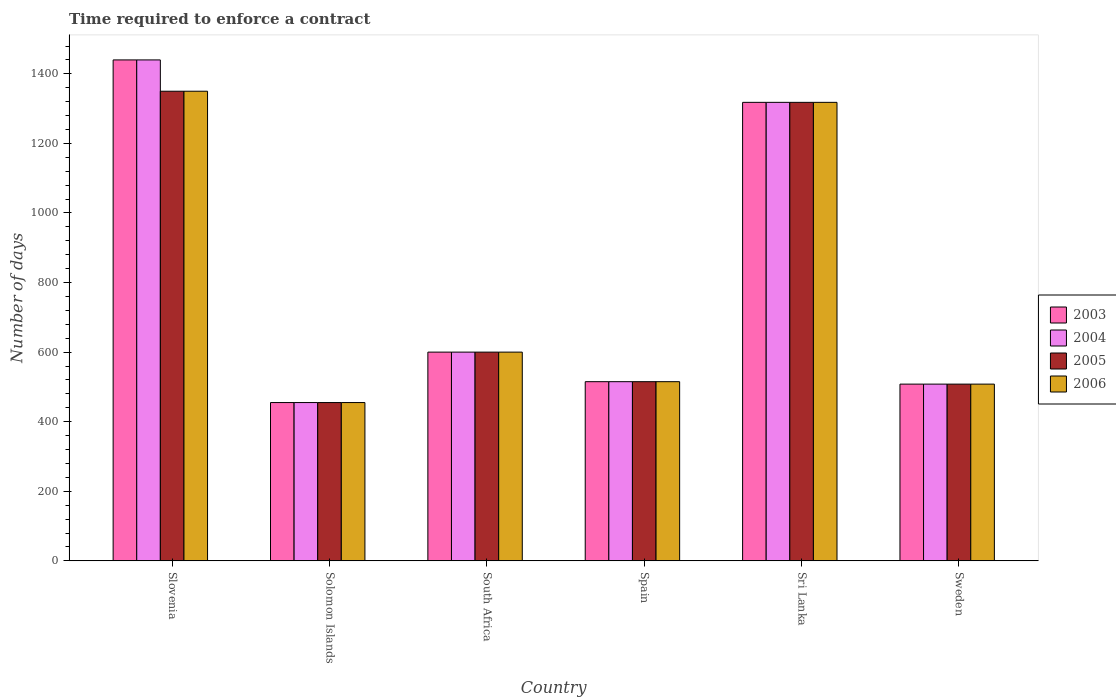How many different coloured bars are there?
Provide a succinct answer. 4. How many groups of bars are there?
Offer a terse response. 6. Are the number of bars per tick equal to the number of legend labels?
Your answer should be very brief. Yes. How many bars are there on the 6th tick from the left?
Offer a very short reply. 4. What is the label of the 5th group of bars from the left?
Give a very brief answer. Sri Lanka. What is the number of days required to enforce a contract in 2005 in Sweden?
Make the answer very short. 508. Across all countries, what is the maximum number of days required to enforce a contract in 2004?
Make the answer very short. 1440. Across all countries, what is the minimum number of days required to enforce a contract in 2005?
Ensure brevity in your answer.  455. In which country was the number of days required to enforce a contract in 2004 maximum?
Offer a very short reply. Slovenia. In which country was the number of days required to enforce a contract in 2004 minimum?
Give a very brief answer. Solomon Islands. What is the total number of days required to enforce a contract in 2006 in the graph?
Your answer should be compact. 4746. What is the difference between the number of days required to enforce a contract in 2003 in South Africa and that in Sri Lanka?
Your answer should be compact. -718. What is the difference between the number of days required to enforce a contract in 2004 in Solomon Islands and the number of days required to enforce a contract in 2003 in South Africa?
Your answer should be compact. -145. What is the average number of days required to enforce a contract in 2003 per country?
Make the answer very short. 806. What is the difference between the number of days required to enforce a contract of/in 2005 and number of days required to enforce a contract of/in 2006 in Slovenia?
Provide a short and direct response. 0. What is the ratio of the number of days required to enforce a contract in 2005 in Solomon Islands to that in Sri Lanka?
Provide a succinct answer. 0.35. Is the number of days required to enforce a contract in 2006 in Slovenia less than that in Sri Lanka?
Keep it short and to the point. No. What is the difference between the highest and the second highest number of days required to enforce a contract in 2004?
Provide a short and direct response. 840. What is the difference between the highest and the lowest number of days required to enforce a contract in 2005?
Offer a terse response. 895. In how many countries, is the number of days required to enforce a contract in 2003 greater than the average number of days required to enforce a contract in 2003 taken over all countries?
Offer a very short reply. 2. Is the sum of the number of days required to enforce a contract in 2006 in Slovenia and Sweden greater than the maximum number of days required to enforce a contract in 2003 across all countries?
Provide a short and direct response. Yes. What does the 1st bar from the right in Slovenia represents?
Your response must be concise. 2006. Are the values on the major ticks of Y-axis written in scientific E-notation?
Ensure brevity in your answer.  No. Does the graph contain grids?
Give a very brief answer. No. Where does the legend appear in the graph?
Your answer should be compact. Center right. How are the legend labels stacked?
Your answer should be compact. Vertical. What is the title of the graph?
Offer a very short reply. Time required to enforce a contract. Does "1986" appear as one of the legend labels in the graph?
Ensure brevity in your answer.  No. What is the label or title of the X-axis?
Ensure brevity in your answer.  Country. What is the label or title of the Y-axis?
Offer a terse response. Number of days. What is the Number of days of 2003 in Slovenia?
Give a very brief answer. 1440. What is the Number of days in 2004 in Slovenia?
Make the answer very short. 1440. What is the Number of days of 2005 in Slovenia?
Ensure brevity in your answer.  1350. What is the Number of days in 2006 in Slovenia?
Ensure brevity in your answer.  1350. What is the Number of days of 2003 in Solomon Islands?
Offer a very short reply. 455. What is the Number of days in 2004 in Solomon Islands?
Make the answer very short. 455. What is the Number of days in 2005 in Solomon Islands?
Offer a very short reply. 455. What is the Number of days of 2006 in Solomon Islands?
Give a very brief answer. 455. What is the Number of days of 2003 in South Africa?
Keep it short and to the point. 600. What is the Number of days in 2004 in South Africa?
Offer a terse response. 600. What is the Number of days in 2005 in South Africa?
Offer a terse response. 600. What is the Number of days of 2006 in South Africa?
Ensure brevity in your answer.  600. What is the Number of days in 2003 in Spain?
Your response must be concise. 515. What is the Number of days in 2004 in Spain?
Your answer should be compact. 515. What is the Number of days in 2005 in Spain?
Provide a succinct answer. 515. What is the Number of days in 2006 in Spain?
Give a very brief answer. 515. What is the Number of days of 2003 in Sri Lanka?
Your answer should be very brief. 1318. What is the Number of days in 2004 in Sri Lanka?
Offer a terse response. 1318. What is the Number of days of 2005 in Sri Lanka?
Offer a very short reply. 1318. What is the Number of days in 2006 in Sri Lanka?
Offer a terse response. 1318. What is the Number of days in 2003 in Sweden?
Your response must be concise. 508. What is the Number of days of 2004 in Sweden?
Ensure brevity in your answer.  508. What is the Number of days of 2005 in Sweden?
Your answer should be very brief. 508. What is the Number of days in 2006 in Sweden?
Offer a terse response. 508. Across all countries, what is the maximum Number of days in 2003?
Your answer should be very brief. 1440. Across all countries, what is the maximum Number of days in 2004?
Give a very brief answer. 1440. Across all countries, what is the maximum Number of days of 2005?
Your answer should be very brief. 1350. Across all countries, what is the maximum Number of days in 2006?
Provide a short and direct response. 1350. Across all countries, what is the minimum Number of days in 2003?
Make the answer very short. 455. Across all countries, what is the minimum Number of days in 2004?
Make the answer very short. 455. Across all countries, what is the minimum Number of days of 2005?
Offer a terse response. 455. Across all countries, what is the minimum Number of days in 2006?
Make the answer very short. 455. What is the total Number of days of 2003 in the graph?
Keep it short and to the point. 4836. What is the total Number of days of 2004 in the graph?
Give a very brief answer. 4836. What is the total Number of days of 2005 in the graph?
Offer a terse response. 4746. What is the total Number of days of 2006 in the graph?
Offer a very short reply. 4746. What is the difference between the Number of days in 2003 in Slovenia and that in Solomon Islands?
Keep it short and to the point. 985. What is the difference between the Number of days of 2004 in Slovenia and that in Solomon Islands?
Ensure brevity in your answer.  985. What is the difference between the Number of days in 2005 in Slovenia and that in Solomon Islands?
Offer a terse response. 895. What is the difference between the Number of days of 2006 in Slovenia and that in Solomon Islands?
Make the answer very short. 895. What is the difference between the Number of days in 2003 in Slovenia and that in South Africa?
Keep it short and to the point. 840. What is the difference between the Number of days of 2004 in Slovenia and that in South Africa?
Ensure brevity in your answer.  840. What is the difference between the Number of days in 2005 in Slovenia and that in South Africa?
Ensure brevity in your answer.  750. What is the difference between the Number of days in 2006 in Slovenia and that in South Africa?
Give a very brief answer. 750. What is the difference between the Number of days of 2003 in Slovenia and that in Spain?
Provide a succinct answer. 925. What is the difference between the Number of days of 2004 in Slovenia and that in Spain?
Offer a terse response. 925. What is the difference between the Number of days of 2005 in Slovenia and that in Spain?
Ensure brevity in your answer.  835. What is the difference between the Number of days of 2006 in Slovenia and that in Spain?
Offer a terse response. 835. What is the difference between the Number of days in 2003 in Slovenia and that in Sri Lanka?
Your answer should be very brief. 122. What is the difference between the Number of days of 2004 in Slovenia and that in Sri Lanka?
Make the answer very short. 122. What is the difference between the Number of days of 2006 in Slovenia and that in Sri Lanka?
Your answer should be compact. 32. What is the difference between the Number of days in 2003 in Slovenia and that in Sweden?
Offer a terse response. 932. What is the difference between the Number of days in 2004 in Slovenia and that in Sweden?
Your answer should be compact. 932. What is the difference between the Number of days in 2005 in Slovenia and that in Sweden?
Offer a very short reply. 842. What is the difference between the Number of days in 2006 in Slovenia and that in Sweden?
Your answer should be very brief. 842. What is the difference between the Number of days of 2003 in Solomon Islands and that in South Africa?
Give a very brief answer. -145. What is the difference between the Number of days in 2004 in Solomon Islands and that in South Africa?
Provide a short and direct response. -145. What is the difference between the Number of days of 2005 in Solomon Islands and that in South Africa?
Provide a short and direct response. -145. What is the difference between the Number of days of 2006 in Solomon Islands and that in South Africa?
Ensure brevity in your answer.  -145. What is the difference between the Number of days of 2003 in Solomon Islands and that in Spain?
Your answer should be compact. -60. What is the difference between the Number of days of 2004 in Solomon Islands and that in Spain?
Give a very brief answer. -60. What is the difference between the Number of days in 2005 in Solomon Islands and that in Spain?
Offer a very short reply. -60. What is the difference between the Number of days of 2006 in Solomon Islands and that in Spain?
Provide a short and direct response. -60. What is the difference between the Number of days in 2003 in Solomon Islands and that in Sri Lanka?
Provide a short and direct response. -863. What is the difference between the Number of days in 2004 in Solomon Islands and that in Sri Lanka?
Provide a short and direct response. -863. What is the difference between the Number of days of 2005 in Solomon Islands and that in Sri Lanka?
Provide a succinct answer. -863. What is the difference between the Number of days in 2006 in Solomon Islands and that in Sri Lanka?
Keep it short and to the point. -863. What is the difference between the Number of days in 2003 in Solomon Islands and that in Sweden?
Make the answer very short. -53. What is the difference between the Number of days in 2004 in Solomon Islands and that in Sweden?
Ensure brevity in your answer.  -53. What is the difference between the Number of days in 2005 in Solomon Islands and that in Sweden?
Your answer should be compact. -53. What is the difference between the Number of days of 2006 in Solomon Islands and that in Sweden?
Offer a terse response. -53. What is the difference between the Number of days in 2003 in South Africa and that in Spain?
Provide a succinct answer. 85. What is the difference between the Number of days in 2004 in South Africa and that in Spain?
Give a very brief answer. 85. What is the difference between the Number of days of 2005 in South Africa and that in Spain?
Provide a succinct answer. 85. What is the difference between the Number of days in 2003 in South Africa and that in Sri Lanka?
Your answer should be very brief. -718. What is the difference between the Number of days of 2004 in South Africa and that in Sri Lanka?
Your response must be concise. -718. What is the difference between the Number of days in 2005 in South Africa and that in Sri Lanka?
Ensure brevity in your answer.  -718. What is the difference between the Number of days in 2006 in South Africa and that in Sri Lanka?
Provide a short and direct response. -718. What is the difference between the Number of days in 2003 in South Africa and that in Sweden?
Make the answer very short. 92. What is the difference between the Number of days in 2004 in South Africa and that in Sweden?
Give a very brief answer. 92. What is the difference between the Number of days in 2005 in South Africa and that in Sweden?
Keep it short and to the point. 92. What is the difference between the Number of days of 2006 in South Africa and that in Sweden?
Your response must be concise. 92. What is the difference between the Number of days in 2003 in Spain and that in Sri Lanka?
Your answer should be compact. -803. What is the difference between the Number of days in 2004 in Spain and that in Sri Lanka?
Your answer should be very brief. -803. What is the difference between the Number of days in 2005 in Spain and that in Sri Lanka?
Your answer should be compact. -803. What is the difference between the Number of days in 2006 in Spain and that in Sri Lanka?
Give a very brief answer. -803. What is the difference between the Number of days of 2003 in Spain and that in Sweden?
Provide a succinct answer. 7. What is the difference between the Number of days of 2005 in Spain and that in Sweden?
Provide a succinct answer. 7. What is the difference between the Number of days in 2006 in Spain and that in Sweden?
Keep it short and to the point. 7. What is the difference between the Number of days of 2003 in Sri Lanka and that in Sweden?
Ensure brevity in your answer.  810. What is the difference between the Number of days of 2004 in Sri Lanka and that in Sweden?
Offer a very short reply. 810. What is the difference between the Number of days of 2005 in Sri Lanka and that in Sweden?
Give a very brief answer. 810. What is the difference between the Number of days of 2006 in Sri Lanka and that in Sweden?
Make the answer very short. 810. What is the difference between the Number of days in 2003 in Slovenia and the Number of days in 2004 in Solomon Islands?
Keep it short and to the point. 985. What is the difference between the Number of days in 2003 in Slovenia and the Number of days in 2005 in Solomon Islands?
Your answer should be very brief. 985. What is the difference between the Number of days in 2003 in Slovenia and the Number of days in 2006 in Solomon Islands?
Ensure brevity in your answer.  985. What is the difference between the Number of days in 2004 in Slovenia and the Number of days in 2005 in Solomon Islands?
Offer a very short reply. 985. What is the difference between the Number of days of 2004 in Slovenia and the Number of days of 2006 in Solomon Islands?
Offer a terse response. 985. What is the difference between the Number of days of 2005 in Slovenia and the Number of days of 2006 in Solomon Islands?
Ensure brevity in your answer.  895. What is the difference between the Number of days of 2003 in Slovenia and the Number of days of 2004 in South Africa?
Provide a short and direct response. 840. What is the difference between the Number of days of 2003 in Slovenia and the Number of days of 2005 in South Africa?
Offer a very short reply. 840. What is the difference between the Number of days in 2003 in Slovenia and the Number of days in 2006 in South Africa?
Make the answer very short. 840. What is the difference between the Number of days of 2004 in Slovenia and the Number of days of 2005 in South Africa?
Give a very brief answer. 840. What is the difference between the Number of days in 2004 in Slovenia and the Number of days in 2006 in South Africa?
Keep it short and to the point. 840. What is the difference between the Number of days in 2005 in Slovenia and the Number of days in 2006 in South Africa?
Provide a short and direct response. 750. What is the difference between the Number of days in 2003 in Slovenia and the Number of days in 2004 in Spain?
Offer a very short reply. 925. What is the difference between the Number of days in 2003 in Slovenia and the Number of days in 2005 in Spain?
Offer a very short reply. 925. What is the difference between the Number of days in 2003 in Slovenia and the Number of days in 2006 in Spain?
Make the answer very short. 925. What is the difference between the Number of days in 2004 in Slovenia and the Number of days in 2005 in Spain?
Your answer should be very brief. 925. What is the difference between the Number of days in 2004 in Slovenia and the Number of days in 2006 in Spain?
Ensure brevity in your answer.  925. What is the difference between the Number of days in 2005 in Slovenia and the Number of days in 2006 in Spain?
Make the answer very short. 835. What is the difference between the Number of days of 2003 in Slovenia and the Number of days of 2004 in Sri Lanka?
Provide a short and direct response. 122. What is the difference between the Number of days in 2003 in Slovenia and the Number of days in 2005 in Sri Lanka?
Give a very brief answer. 122. What is the difference between the Number of days in 2003 in Slovenia and the Number of days in 2006 in Sri Lanka?
Make the answer very short. 122. What is the difference between the Number of days of 2004 in Slovenia and the Number of days of 2005 in Sri Lanka?
Your answer should be compact. 122. What is the difference between the Number of days of 2004 in Slovenia and the Number of days of 2006 in Sri Lanka?
Your response must be concise. 122. What is the difference between the Number of days in 2003 in Slovenia and the Number of days in 2004 in Sweden?
Offer a very short reply. 932. What is the difference between the Number of days in 2003 in Slovenia and the Number of days in 2005 in Sweden?
Offer a very short reply. 932. What is the difference between the Number of days in 2003 in Slovenia and the Number of days in 2006 in Sweden?
Your response must be concise. 932. What is the difference between the Number of days in 2004 in Slovenia and the Number of days in 2005 in Sweden?
Your answer should be compact. 932. What is the difference between the Number of days of 2004 in Slovenia and the Number of days of 2006 in Sweden?
Offer a terse response. 932. What is the difference between the Number of days of 2005 in Slovenia and the Number of days of 2006 in Sweden?
Your answer should be compact. 842. What is the difference between the Number of days in 2003 in Solomon Islands and the Number of days in 2004 in South Africa?
Ensure brevity in your answer.  -145. What is the difference between the Number of days of 2003 in Solomon Islands and the Number of days of 2005 in South Africa?
Your answer should be compact. -145. What is the difference between the Number of days of 2003 in Solomon Islands and the Number of days of 2006 in South Africa?
Offer a terse response. -145. What is the difference between the Number of days in 2004 in Solomon Islands and the Number of days in 2005 in South Africa?
Your answer should be very brief. -145. What is the difference between the Number of days in 2004 in Solomon Islands and the Number of days in 2006 in South Africa?
Your answer should be very brief. -145. What is the difference between the Number of days of 2005 in Solomon Islands and the Number of days of 2006 in South Africa?
Offer a terse response. -145. What is the difference between the Number of days in 2003 in Solomon Islands and the Number of days in 2004 in Spain?
Make the answer very short. -60. What is the difference between the Number of days in 2003 in Solomon Islands and the Number of days in 2005 in Spain?
Ensure brevity in your answer.  -60. What is the difference between the Number of days in 2003 in Solomon Islands and the Number of days in 2006 in Spain?
Offer a terse response. -60. What is the difference between the Number of days in 2004 in Solomon Islands and the Number of days in 2005 in Spain?
Your answer should be very brief. -60. What is the difference between the Number of days in 2004 in Solomon Islands and the Number of days in 2006 in Spain?
Offer a terse response. -60. What is the difference between the Number of days of 2005 in Solomon Islands and the Number of days of 2006 in Spain?
Your answer should be very brief. -60. What is the difference between the Number of days of 2003 in Solomon Islands and the Number of days of 2004 in Sri Lanka?
Give a very brief answer. -863. What is the difference between the Number of days in 2003 in Solomon Islands and the Number of days in 2005 in Sri Lanka?
Ensure brevity in your answer.  -863. What is the difference between the Number of days in 2003 in Solomon Islands and the Number of days in 2006 in Sri Lanka?
Keep it short and to the point. -863. What is the difference between the Number of days in 2004 in Solomon Islands and the Number of days in 2005 in Sri Lanka?
Provide a succinct answer. -863. What is the difference between the Number of days of 2004 in Solomon Islands and the Number of days of 2006 in Sri Lanka?
Offer a very short reply. -863. What is the difference between the Number of days of 2005 in Solomon Islands and the Number of days of 2006 in Sri Lanka?
Your answer should be very brief. -863. What is the difference between the Number of days of 2003 in Solomon Islands and the Number of days of 2004 in Sweden?
Ensure brevity in your answer.  -53. What is the difference between the Number of days in 2003 in Solomon Islands and the Number of days in 2005 in Sweden?
Offer a very short reply. -53. What is the difference between the Number of days of 2003 in Solomon Islands and the Number of days of 2006 in Sweden?
Offer a terse response. -53. What is the difference between the Number of days in 2004 in Solomon Islands and the Number of days in 2005 in Sweden?
Provide a short and direct response. -53. What is the difference between the Number of days of 2004 in Solomon Islands and the Number of days of 2006 in Sweden?
Ensure brevity in your answer.  -53. What is the difference between the Number of days of 2005 in Solomon Islands and the Number of days of 2006 in Sweden?
Your answer should be very brief. -53. What is the difference between the Number of days in 2003 in South Africa and the Number of days in 2004 in Spain?
Your response must be concise. 85. What is the difference between the Number of days in 2004 in South Africa and the Number of days in 2005 in Spain?
Your answer should be compact. 85. What is the difference between the Number of days in 2005 in South Africa and the Number of days in 2006 in Spain?
Provide a succinct answer. 85. What is the difference between the Number of days of 2003 in South Africa and the Number of days of 2004 in Sri Lanka?
Make the answer very short. -718. What is the difference between the Number of days in 2003 in South Africa and the Number of days in 2005 in Sri Lanka?
Make the answer very short. -718. What is the difference between the Number of days of 2003 in South Africa and the Number of days of 2006 in Sri Lanka?
Your answer should be very brief. -718. What is the difference between the Number of days of 2004 in South Africa and the Number of days of 2005 in Sri Lanka?
Provide a short and direct response. -718. What is the difference between the Number of days of 2004 in South Africa and the Number of days of 2006 in Sri Lanka?
Keep it short and to the point. -718. What is the difference between the Number of days in 2005 in South Africa and the Number of days in 2006 in Sri Lanka?
Make the answer very short. -718. What is the difference between the Number of days in 2003 in South Africa and the Number of days in 2004 in Sweden?
Keep it short and to the point. 92. What is the difference between the Number of days of 2003 in South Africa and the Number of days of 2005 in Sweden?
Your answer should be compact. 92. What is the difference between the Number of days of 2003 in South Africa and the Number of days of 2006 in Sweden?
Make the answer very short. 92. What is the difference between the Number of days in 2004 in South Africa and the Number of days in 2005 in Sweden?
Offer a very short reply. 92. What is the difference between the Number of days of 2004 in South Africa and the Number of days of 2006 in Sweden?
Your answer should be compact. 92. What is the difference between the Number of days of 2005 in South Africa and the Number of days of 2006 in Sweden?
Your answer should be compact. 92. What is the difference between the Number of days in 2003 in Spain and the Number of days in 2004 in Sri Lanka?
Provide a short and direct response. -803. What is the difference between the Number of days in 2003 in Spain and the Number of days in 2005 in Sri Lanka?
Provide a short and direct response. -803. What is the difference between the Number of days of 2003 in Spain and the Number of days of 2006 in Sri Lanka?
Make the answer very short. -803. What is the difference between the Number of days in 2004 in Spain and the Number of days in 2005 in Sri Lanka?
Ensure brevity in your answer.  -803. What is the difference between the Number of days of 2004 in Spain and the Number of days of 2006 in Sri Lanka?
Provide a short and direct response. -803. What is the difference between the Number of days in 2005 in Spain and the Number of days in 2006 in Sri Lanka?
Your response must be concise. -803. What is the difference between the Number of days of 2003 in Spain and the Number of days of 2004 in Sweden?
Offer a very short reply. 7. What is the difference between the Number of days of 2003 in Spain and the Number of days of 2006 in Sweden?
Keep it short and to the point. 7. What is the difference between the Number of days in 2004 in Spain and the Number of days in 2005 in Sweden?
Make the answer very short. 7. What is the difference between the Number of days in 2003 in Sri Lanka and the Number of days in 2004 in Sweden?
Your answer should be compact. 810. What is the difference between the Number of days of 2003 in Sri Lanka and the Number of days of 2005 in Sweden?
Your response must be concise. 810. What is the difference between the Number of days of 2003 in Sri Lanka and the Number of days of 2006 in Sweden?
Your answer should be very brief. 810. What is the difference between the Number of days in 2004 in Sri Lanka and the Number of days in 2005 in Sweden?
Give a very brief answer. 810. What is the difference between the Number of days of 2004 in Sri Lanka and the Number of days of 2006 in Sweden?
Provide a succinct answer. 810. What is the difference between the Number of days in 2005 in Sri Lanka and the Number of days in 2006 in Sweden?
Your answer should be compact. 810. What is the average Number of days of 2003 per country?
Offer a terse response. 806. What is the average Number of days of 2004 per country?
Your answer should be compact. 806. What is the average Number of days in 2005 per country?
Give a very brief answer. 791. What is the average Number of days of 2006 per country?
Your answer should be very brief. 791. What is the difference between the Number of days of 2003 and Number of days of 2004 in Slovenia?
Offer a very short reply. 0. What is the difference between the Number of days of 2003 and Number of days of 2005 in Slovenia?
Provide a short and direct response. 90. What is the difference between the Number of days of 2003 and Number of days of 2004 in Solomon Islands?
Offer a terse response. 0. What is the difference between the Number of days of 2003 and Number of days of 2005 in Solomon Islands?
Your answer should be very brief. 0. What is the difference between the Number of days of 2003 and Number of days of 2006 in Solomon Islands?
Offer a very short reply. 0. What is the difference between the Number of days of 2004 and Number of days of 2005 in Solomon Islands?
Offer a terse response. 0. What is the difference between the Number of days in 2004 and Number of days in 2006 in Solomon Islands?
Your response must be concise. 0. What is the difference between the Number of days in 2003 and Number of days in 2005 in South Africa?
Your answer should be very brief. 0. What is the difference between the Number of days in 2003 and Number of days in 2004 in Spain?
Ensure brevity in your answer.  0. What is the difference between the Number of days of 2004 and Number of days of 2005 in Spain?
Provide a short and direct response. 0. What is the difference between the Number of days in 2004 and Number of days in 2006 in Spain?
Keep it short and to the point. 0. What is the difference between the Number of days of 2003 and Number of days of 2004 in Sri Lanka?
Your response must be concise. 0. What is the difference between the Number of days in 2003 and Number of days in 2006 in Sri Lanka?
Provide a succinct answer. 0. What is the difference between the Number of days of 2004 and Number of days of 2005 in Sri Lanka?
Ensure brevity in your answer.  0. What is the difference between the Number of days of 2005 and Number of days of 2006 in Sri Lanka?
Offer a terse response. 0. What is the difference between the Number of days of 2003 and Number of days of 2006 in Sweden?
Your response must be concise. 0. What is the difference between the Number of days of 2004 and Number of days of 2005 in Sweden?
Provide a succinct answer. 0. What is the difference between the Number of days in 2004 and Number of days in 2006 in Sweden?
Your answer should be very brief. 0. What is the ratio of the Number of days in 2003 in Slovenia to that in Solomon Islands?
Your answer should be compact. 3.16. What is the ratio of the Number of days in 2004 in Slovenia to that in Solomon Islands?
Give a very brief answer. 3.16. What is the ratio of the Number of days of 2005 in Slovenia to that in Solomon Islands?
Your answer should be very brief. 2.97. What is the ratio of the Number of days of 2006 in Slovenia to that in Solomon Islands?
Make the answer very short. 2.97. What is the ratio of the Number of days of 2003 in Slovenia to that in South Africa?
Keep it short and to the point. 2.4. What is the ratio of the Number of days in 2004 in Slovenia to that in South Africa?
Ensure brevity in your answer.  2.4. What is the ratio of the Number of days of 2005 in Slovenia to that in South Africa?
Offer a terse response. 2.25. What is the ratio of the Number of days in 2006 in Slovenia to that in South Africa?
Give a very brief answer. 2.25. What is the ratio of the Number of days in 2003 in Slovenia to that in Spain?
Offer a very short reply. 2.8. What is the ratio of the Number of days in 2004 in Slovenia to that in Spain?
Make the answer very short. 2.8. What is the ratio of the Number of days in 2005 in Slovenia to that in Spain?
Keep it short and to the point. 2.62. What is the ratio of the Number of days in 2006 in Slovenia to that in Spain?
Provide a short and direct response. 2.62. What is the ratio of the Number of days of 2003 in Slovenia to that in Sri Lanka?
Give a very brief answer. 1.09. What is the ratio of the Number of days of 2004 in Slovenia to that in Sri Lanka?
Keep it short and to the point. 1.09. What is the ratio of the Number of days in 2005 in Slovenia to that in Sri Lanka?
Offer a terse response. 1.02. What is the ratio of the Number of days in 2006 in Slovenia to that in Sri Lanka?
Provide a succinct answer. 1.02. What is the ratio of the Number of days of 2003 in Slovenia to that in Sweden?
Your answer should be very brief. 2.83. What is the ratio of the Number of days in 2004 in Slovenia to that in Sweden?
Offer a very short reply. 2.83. What is the ratio of the Number of days of 2005 in Slovenia to that in Sweden?
Provide a succinct answer. 2.66. What is the ratio of the Number of days of 2006 in Slovenia to that in Sweden?
Your response must be concise. 2.66. What is the ratio of the Number of days in 2003 in Solomon Islands to that in South Africa?
Give a very brief answer. 0.76. What is the ratio of the Number of days in 2004 in Solomon Islands to that in South Africa?
Your answer should be very brief. 0.76. What is the ratio of the Number of days of 2005 in Solomon Islands to that in South Africa?
Your answer should be compact. 0.76. What is the ratio of the Number of days in 2006 in Solomon Islands to that in South Africa?
Offer a very short reply. 0.76. What is the ratio of the Number of days of 2003 in Solomon Islands to that in Spain?
Keep it short and to the point. 0.88. What is the ratio of the Number of days of 2004 in Solomon Islands to that in Spain?
Provide a succinct answer. 0.88. What is the ratio of the Number of days of 2005 in Solomon Islands to that in Spain?
Your response must be concise. 0.88. What is the ratio of the Number of days of 2006 in Solomon Islands to that in Spain?
Your response must be concise. 0.88. What is the ratio of the Number of days of 2003 in Solomon Islands to that in Sri Lanka?
Give a very brief answer. 0.35. What is the ratio of the Number of days in 2004 in Solomon Islands to that in Sri Lanka?
Give a very brief answer. 0.35. What is the ratio of the Number of days in 2005 in Solomon Islands to that in Sri Lanka?
Give a very brief answer. 0.35. What is the ratio of the Number of days in 2006 in Solomon Islands to that in Sri Lanka?
Make the answer very short. 0.35. What is the ratio of the Number of days of 2003 in Solomon Islands to that in Sweden?
Keep it short and to the point. 0.9. What is the ratio of the Number of days of 2004 in Solomon Islands to that in Sweden?
Offer a very short reply. 0.9. What is the ratio of the Number of days of 2005 in Solomon Islands to that in Sweden?
Keep it short and to the point. 0.9. What is the ratio of the Number of days in 2006 in Solomon Islands to that in Sweden?
Make the answer very short. 0.9. What is the ratio of the Number of days of 2003 in South Africa to that in Spain?
Provide a short and direct response. 1.17. What is the ratio of the Number of days of 2004 in South Africa to that in Spain?
Make the answer very short. 1.17. What is the ratio of the Number of days of 2005 in South Africa to that in Spain?
Offer a terse response. 1.17. What is the ratio of the Number of days in 2006 in South Africa to that in Spain?
Your answer should be compact. 1.17. What is the ratio of the Number of days in 2003 in South Africa to that in Sri Lanka?
Ensure brevity in your answer.  0.46. What is the ratio of the Number of days in 2004 in South Africa to that in Sri Lanka?
Make the answer very short. 0.46. What is the ratio of the Number of days of 2005 in South Africa to that in Sri Lanka?
Make the answer very short. 0.46. What is the ratio of the Number of days in 2006 in South Africa to that in Sri Lanka?
Offer a terse response. 0.46. What is the ratio of the Number of days of 2003 in South Africa to that in Sweden?
Offer a terse response. 1.18. What is the ratio of the Number of days in 2004 in South Africa to that in Sweden?
Keep it short and to the point. 1.18. What is the ratio of the Number of days of 2005 in South Africa to that in Sweden?
Offer a terse response. 1.18. What is the ratio of the Number of days of 2006 in South Africa to that in Sweden?
Your response must be concise. 1.18. What is the ratio of the Number of days of 2003 in Spain to that in Sri Lanka?
Make the answer very short. 0.39. What is the ratio of the Number of days of 2004 in Spain to that in Sri Lanka?
Provide a succinct answer. 0.39. What is the ratio of the Number of days of 2005 in Spain to that in Sri Lanka?
Make the answer very short. 0.39. What is the ratio of the Number of days of 2006 in Spain to that in Sri Lanka?
Provide a succinct answer. 0.39. What is the ratio of the Number of days in 2003 in Spain to that in Sweden?
Your response must be concise. 1.01. What is the ratio of the Number of days of 2004 in Spain to that in Sweden?
Provide a succinct answer. 1.01. What is the ratio of the Number of days of 2005 in Spain to that in Sweden?
Give a very brief answer. 1.01. What is the ratio of the Number of days of 2006 in Spain to that in Sweden?
Offer a terse response. 1.01. What is the ratio of the Number of days in 2003 in Sri Lanka to that in Sweden?
Make the answer very short. 2.59. What is the ratio of the Number of days of 2004 in Sri Lanka to that in Sweden?
Your response must be concise. 2.59. What is the ratio of the Number of days of 2005 in Sri Lanka to that in Sweden?
Offer a very short reply. 2.59. What is the ratio of the Number of days of 2006 in Sri Lanka to that in Sweden?
Keep it short and to the point. 2.59. What is the difference between the highest and the second highest Number of days in 2003?
Offer a terse response. 122. What is the difference between the highest and the second highest Number of days in 2004?
Ensure brevity in your answer.  122. What is the difference between the highest and the second highest Number of days of 2005?
Your answer should be compact. 32. What is the difference between the highest and the second highest Number of days in 2006?
Keep it short and to the point. 32. What is the difference between the highest and the lowest Number of days in 2003?
Offer a very short reply. 985. What is the difference between the highest and the lowest Number of days of 2004?
Your answer should be compact. 985. What is the difference between the highest and the lowest Number of days of 2005?
Keep it short and to the point. 895. What is the difference between the highest and the lowest Number of days in 2006?
Make the answer very short. 895. 